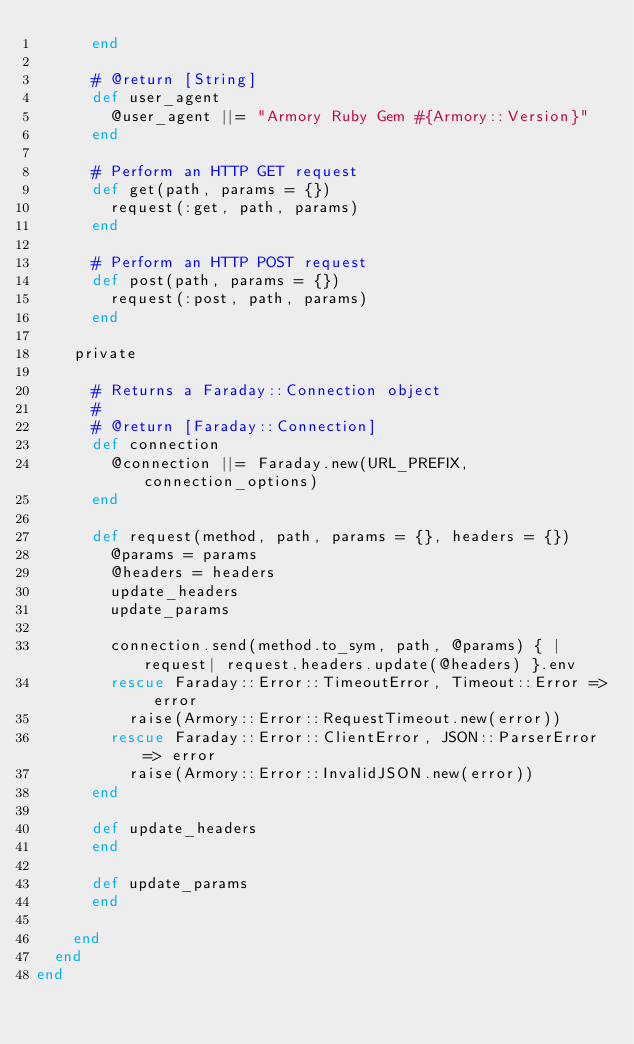Convert code to text. <code><loc_0><loc_0><loc_500><loc_500><_Ruby_>      end

      # @return [String]
      def user_agent
        @user_agent ||= "Armory Ruby Gem #{Armory::Version}"
      end

      # Perform an HTTP GET request
      def get(path, params = {})
        request(:get, path, params)
      end

      # Perform an HTTP POST request
      def post(path, params = {})
        request(:post, path, params)
      end

    private

      # Returns a Faraday::Connection object
      #
      # @return [Faraday::Connection]
      def connection
        @connection ||= Faraday.new(URL_PREFIX, connection_options)
      end

      def request(method, path, params = {}, headers = {})
        @params = params
        @headers = headers
        update_headers
        update_params

        connection.send(method.to_sym, path, @params) { |request| request.headers.update(@headers) }.env
        rescue Faraday::Error::TimeoutError, Timeout::Error => error
          raise(Armory::Error::RequestTimeout.new(error))
        rescue Faraday::Error::ClientError, JSON::ParserError => error
          raise(Armory::Error::InvalidJSON.new(error))
      end

      def update_headers
      end

      def update_params
      end

    end
  end
end
</code> 